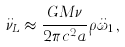<formula> <loc_0><loc_0><loc_500><loc_500>\ddot { \nu } _ { L } \approx \frac { G M \nu } { 2 \pi c ^ { 2 } a } \rho \ddot { \omega } _ { 1 } \, ,</formula> 